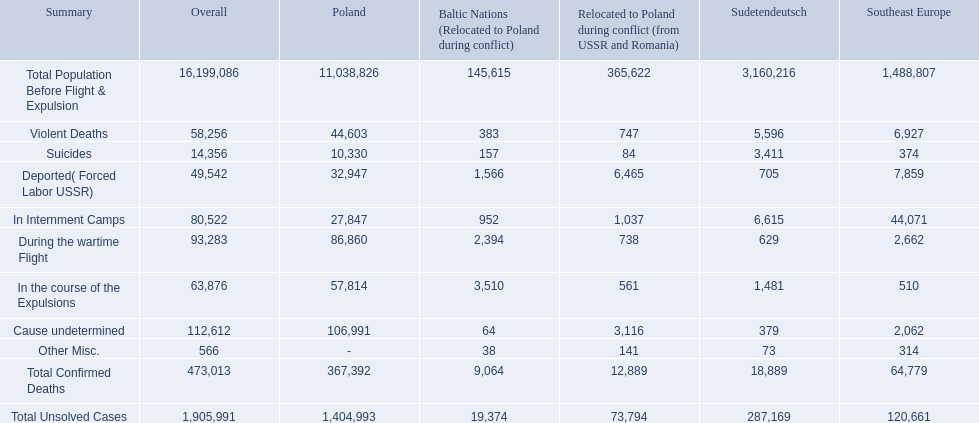What were all of the types of deaths? Violent Deaths, Suicides, Deported( Forced Labor USSR), In Internment Camps, During the wartime Flight, In the course of the Expulsions, Cause undetermined, Other Misc. And their totals in the baltic states? 383, 157, 1,566, 952, 2,394, 3,510, 64, 38. Were more deaths in the baltic states caused by undetermined causes or misc.? Cause undetermined. 